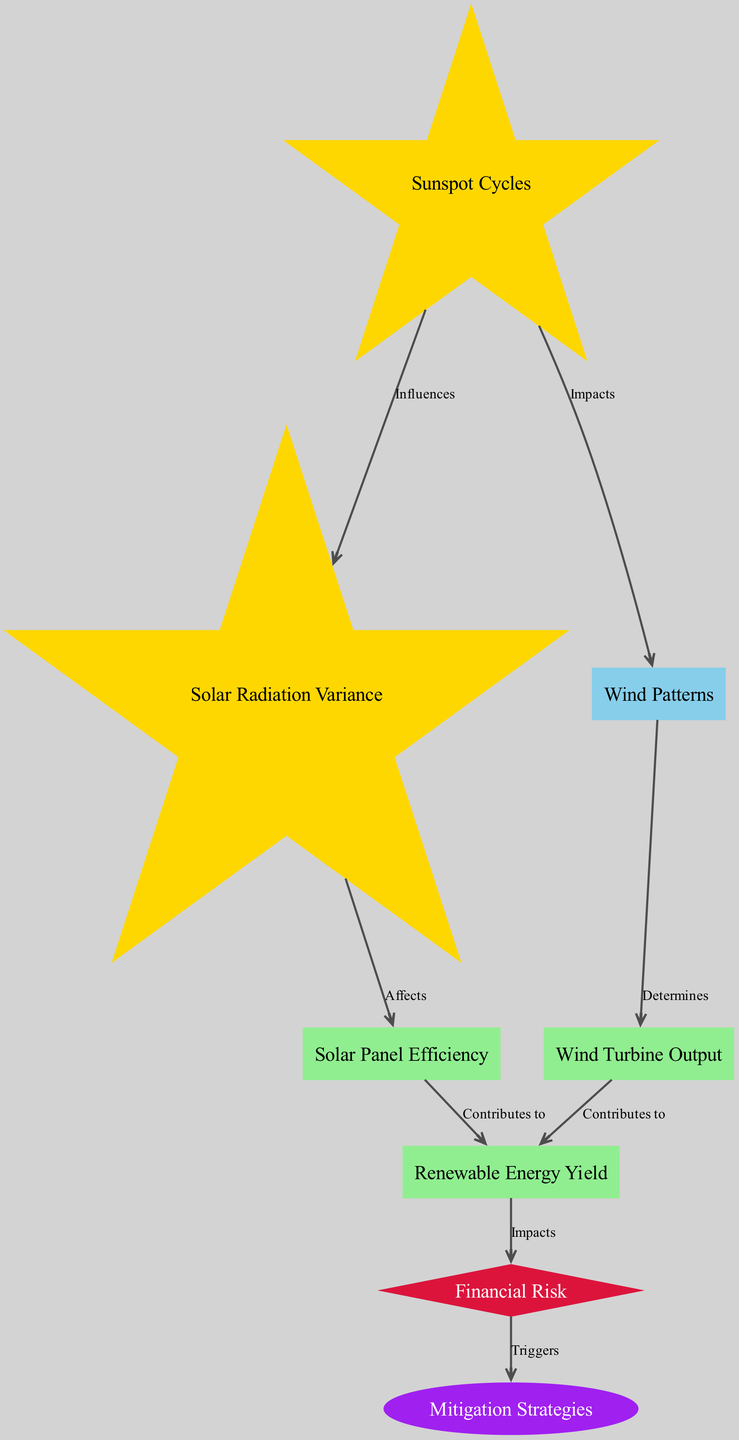What node influences solar radiation variance? The diagram indicates that "Sunspot Cycles" influences "Solar Radiation Variance" as they are directly connected with the label "Influences".
Answer: Sunspot Cycles How many performance nodes are depicted in this diagram? The diagram features three performance nodes: "Solar Panel Efficiency", "Wind Turbine Output", and "Renewable Energy Yield". Counting these nodes leads to a total of three.
Answer: 3 What impacts wind patterns according to the diagram? The diagram shows that "Sunspot Cycles" impacts "Wind Patterns", as indicated by the direct connection labeled "Impacts".
Answer: Sunspot Cycles Which node contributes to renewable energy yield alongside solar panel efficiency? According to the diagram, "Wind Turbine Output" also contributes to "Renewable Energy Yield". This is clear from the edge indicating the relationship between these two nodes labeled "Contributes to".
Answer: Wind Turbine Output What triggers the mitigation strategies in this diagram? The diagram specifies that "Financial Risk" triggers "Mitigation Strategies", demonstrating a flow from risk to action. There is a clear edge labeled "Triggers" between these two nodes.
Answer: Financial Risk What is the relationship between wind patterns and wind turbine output? The diagram illustrates that "Wind Patterns" determine "Wind Turbine Output", as shown by the directed edge that connects them labeled "Determines".
Answer: Determines How does solar radiation variance affect solar panel efficiency? The diagram indicates that "Solar Radiation Variance" affects "Solar Panel Efficiency", as highlighted by the edge labeled "Affects". This demonstrates a direct influence from one node to the other.
Answer: Affects Which node impacts financial risk through renewable energy yield? The diagram states that "Renewable Energy Yield" impacts "Financial Risk", demonstrating the direct influence of energy performance on financial aspects.
Answer: Renewable Energy Yield How many edges are there in total in this diagram? The diagram contains eight edges, as indicated by the connections between the nodes. Each relationship represented in the diagram counts as one edge.
Answer: 8 